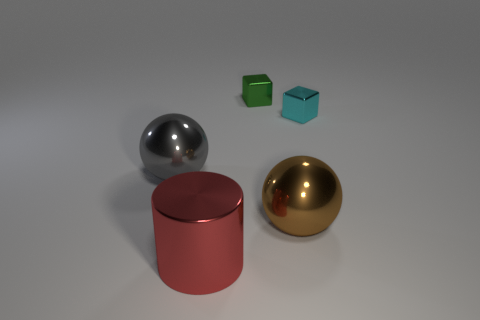Add 3 yellow rubber cylinders. How many objects exist? 8 Subtract all balls. How many objects are left? 3 Add 2 cyan metal cubes. How many cyan metal cubes exist? 3 Subtract 1 gray spheres. How many objects are left? 4 Subtract all small blue metal things. Subtract all big brown shiny spheres. How many objects are left? 4 Add 1 brown shiny objects. How many brown shiny objects are left? 2 